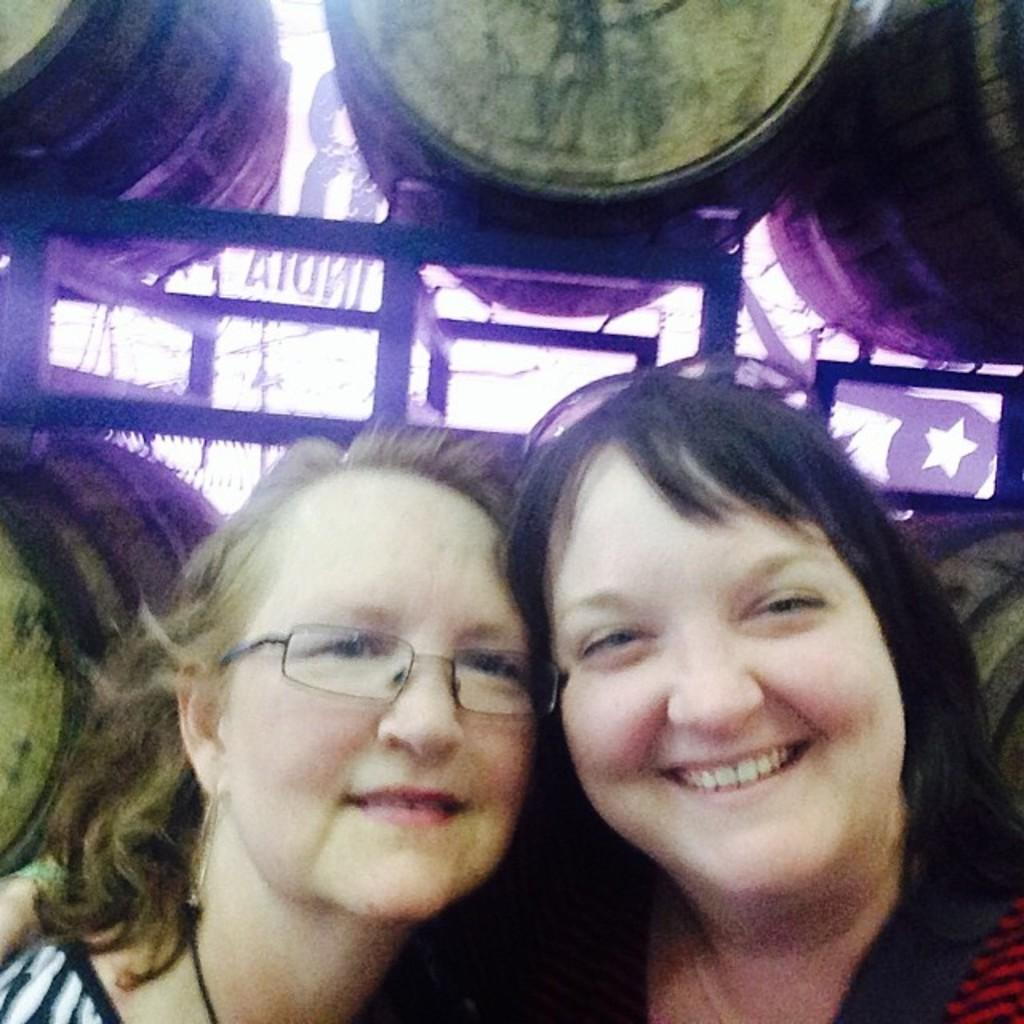How many women are present in the image? There are two women in the image. What is the facial expression of the women? Both women are smiling. Can you describe any accessories worn by the women? One of the women is wearing spectacles. What can be seen in the background of the image? There are barrels visible in the background of the image. What type of agreement did the women reach in the image? There is no indication in the image that the women reached any agreement, as the image only shows them smiling and wearing spectacles. 